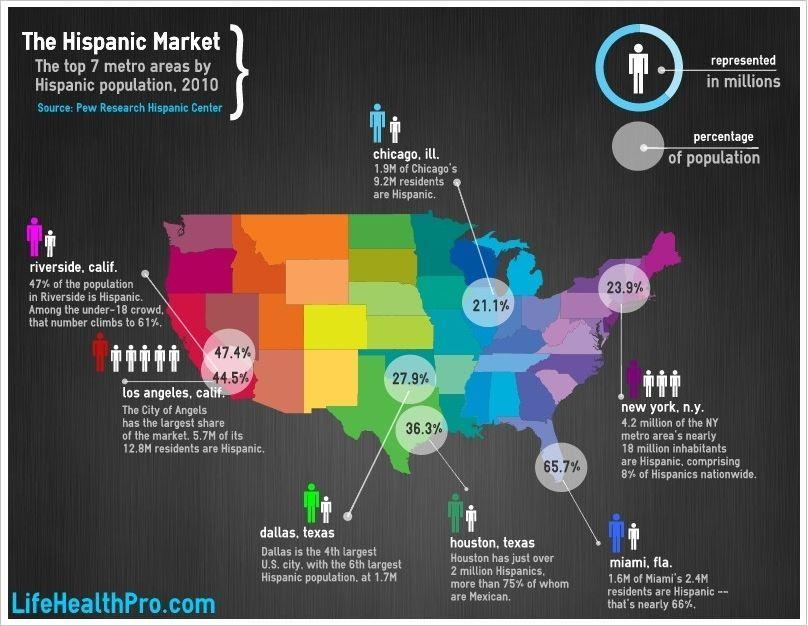What is the number of residents in Chicago who are not Hispanic?
Answer the question with a short phrase. 7.3M What percentage of the population in Riverside is not Hispanic? 53% What percentage of the population of Chicago is not Hispanic? 78.9% What percentage of the population of Miami is not Hispanic? 34% What is the number of residents in Los Angeles who are not Hispanic? 7.1M What percentage of the population of New York is not Hispanic? 76.1% 